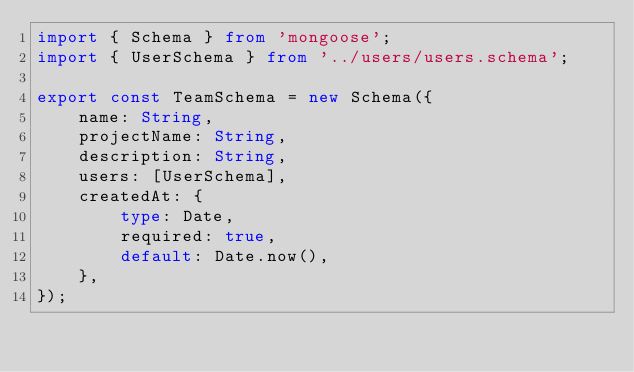<code> <loc_0><loc_0><loc_500><loc_500><_TypeScript_>import { Schema } from 'mongoose';
import { UserSchema } from '../users/users.schema';

export const TeamSchema = new Schema({
    name: String,
    projectName: String,
    description: String,
    users: [UserSchema],
    createdAt: {
        type: Date,
        required: true,
        default: Date.now(),
    },
});
</code> 